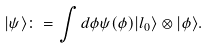Convert formula to latex. <formula><loc_0><loc_0><loc_500><loc_500>| \psi \rangle \colon = \int d \phi \psi ( \phi ) | l _ { 0 } \rangle \otimes | \phi \rangle .</formula> 